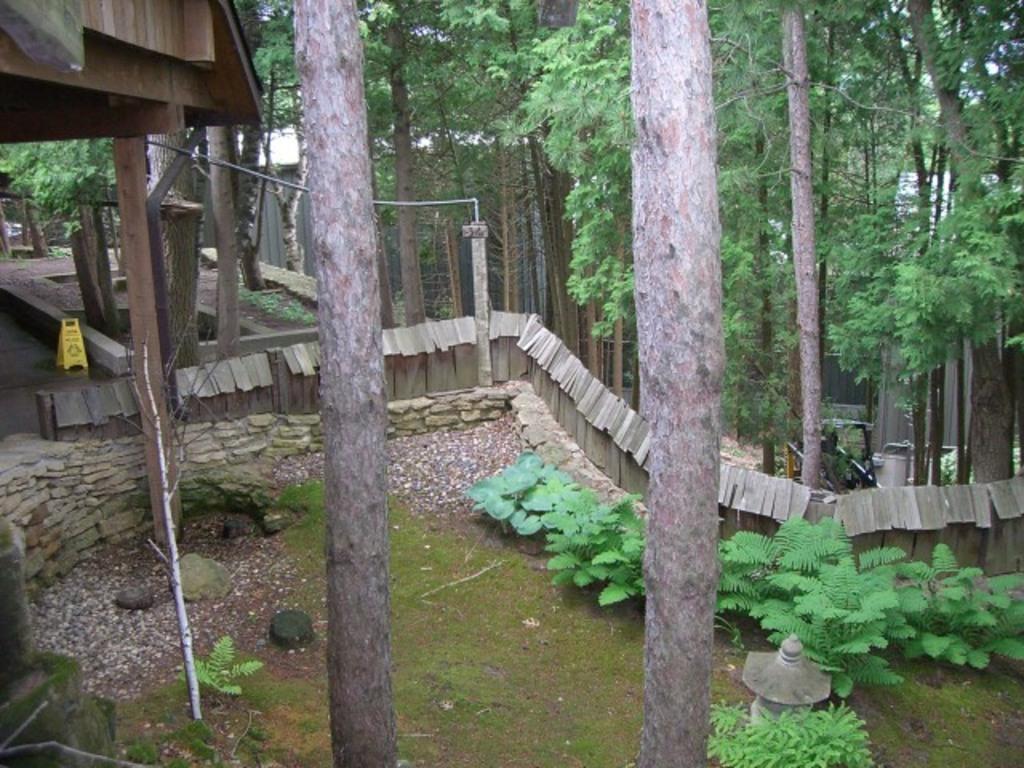How would you summarize this image in a sentence or two? This picture consists of group of trees and fence visible in the middle , in front of fence I can see a pole and plants some stones and a crane visible back side of fence , and a tent house visible in the middle on the left side I can see wooden tent and yellow color stand kept on floor 